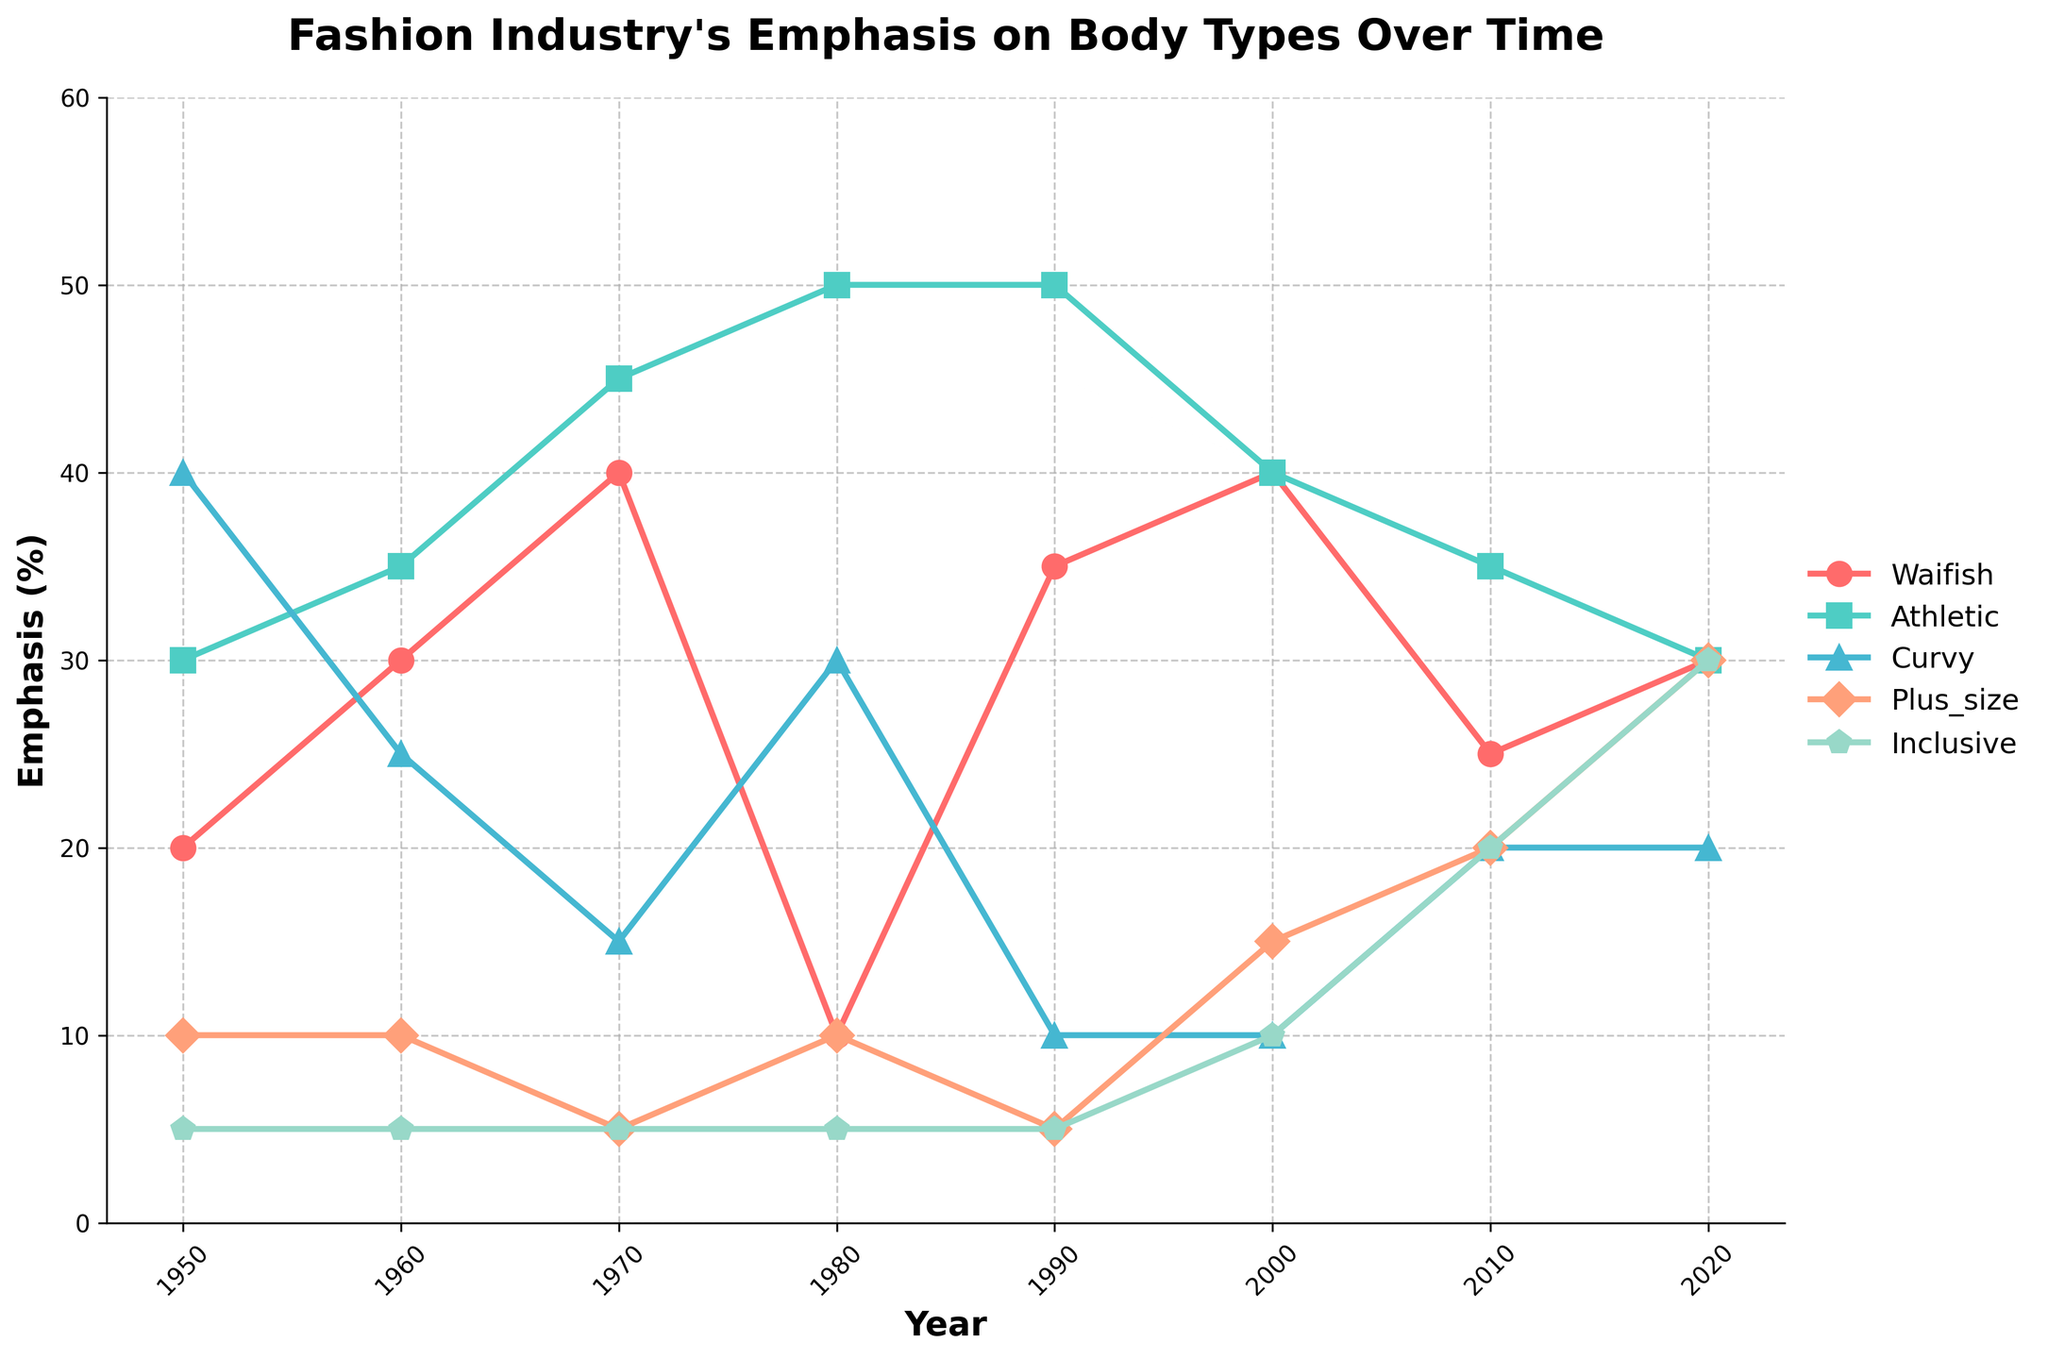What's the title of the figure? The title of the figure is placed at the top of the chart and is displayed in a bold, larger font. The title is "Fashion Industry's Emphasis on Body Types Over Time".
Answer: Fashion Industry's Emphasis on Body Types Over Time How does the emphasis on 'waifish' body types change from 1950 to 1980? Look at the 'waifish' line plot marked with circles. In 1950, the emphasis starts at 20%. By 1980, it drops significantly to 10%.
Answer: It decreases In which year was the emphasis on 'inclusive' body types equal to the sum of 'curvy' and 'plus size' body types? Examine the values of 'inclusive,' 'curvy,' and 'plus size' body types over the years. In 2020, 'inclusive' is 30%, which equals the sum of 'curvy' (20%) and 'plus size' (10%).
Answer: 2020 Which body type had the highest emphasis in 1990? Look at the line with the different markers for the year 1990. The 'athletic' body type line (square marker) is the highest, with 50%.
Answer: Athletic Calculate the average emphasis on 'curvy' body types from 2000 to 2020. Identify the values of 'curvy' body types for the years 2000, 2010, and 2020 (10%, 20%, and 20%, respectively). Sum these values (10 + 20 + 20 = 50) and divide by 3 (years) for the average.
Answer: 16.67% What's the difference in emphasis on 'plus size' body types between 2010 and 2020? Note the 'plus size' values in 2010 (20%) and in 2020 (30%). Subtract the 2010 value from the 2020 value (30% - 20% = 10%).
Answer: 10% Which two body types had the same emphasis in the year 2020? In the year 2020, the lines for 'waifish' and 'athletic' intersect at 30%, indicating they had the same emphasis.
Answer: Waifish and Athletic What trend can be observed for 'inclusive' body type emphasis from 1950 to 2020? Trace the line marked for 'inclusive' body types. It starts at 5% in 1950 and gradually increases to reach 30% in 2020, indicating a rising trend.
Answer: An increasing trend How many body types had an emphasis less than 20% in 1980? Examine the 'waifish,' 'athletic,' 'curvy,' 'plus size,' and 'inclusive' values for 1980. Only 'waifish' and 'inclusive' are less than 20% (10% and 5% respectively).
Answer: Total 2 body types During which decade did 'athletic' body types see the most substantial increase in emphasis? Look at the 'athletic' body type line, noting the differences between each decade. The biggest increase happened between 1970 (45%) and 1980 (50%).
Answer: 1970s 